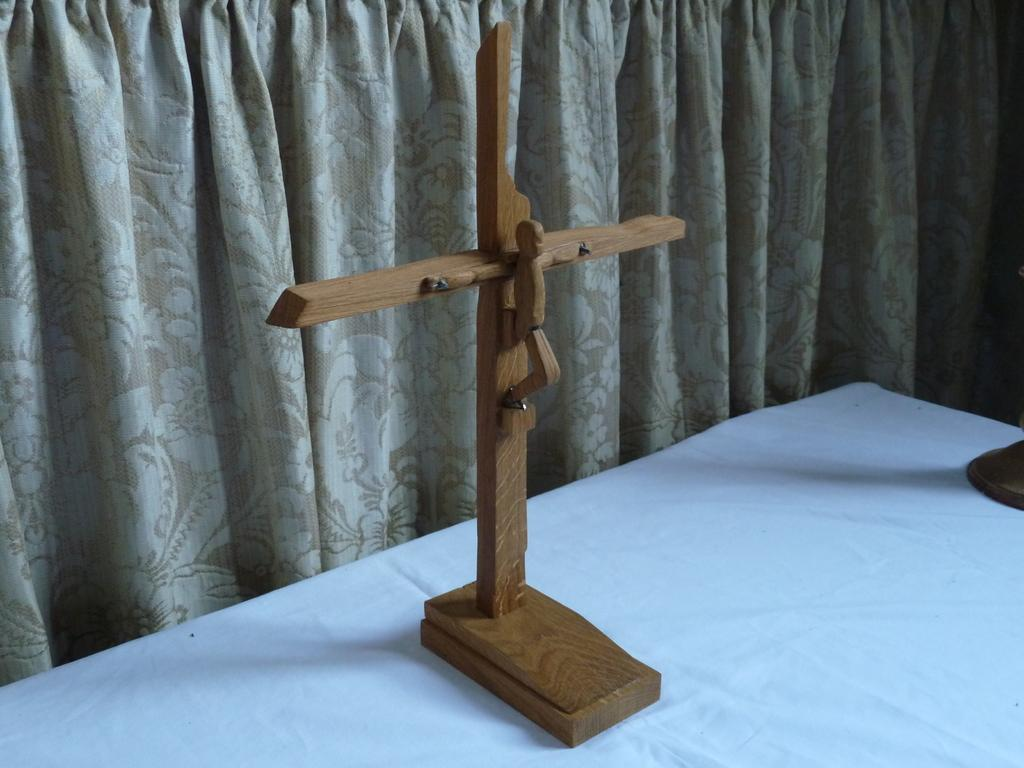What object is placed on the table in the image? There is a cross placed on a table in the image. What can be seen in the background of the image? There is a curtain in the background of the image. What color is the orange thing on the table in the image? There is no orange thing present in the image; the main object on the table is a cross. 